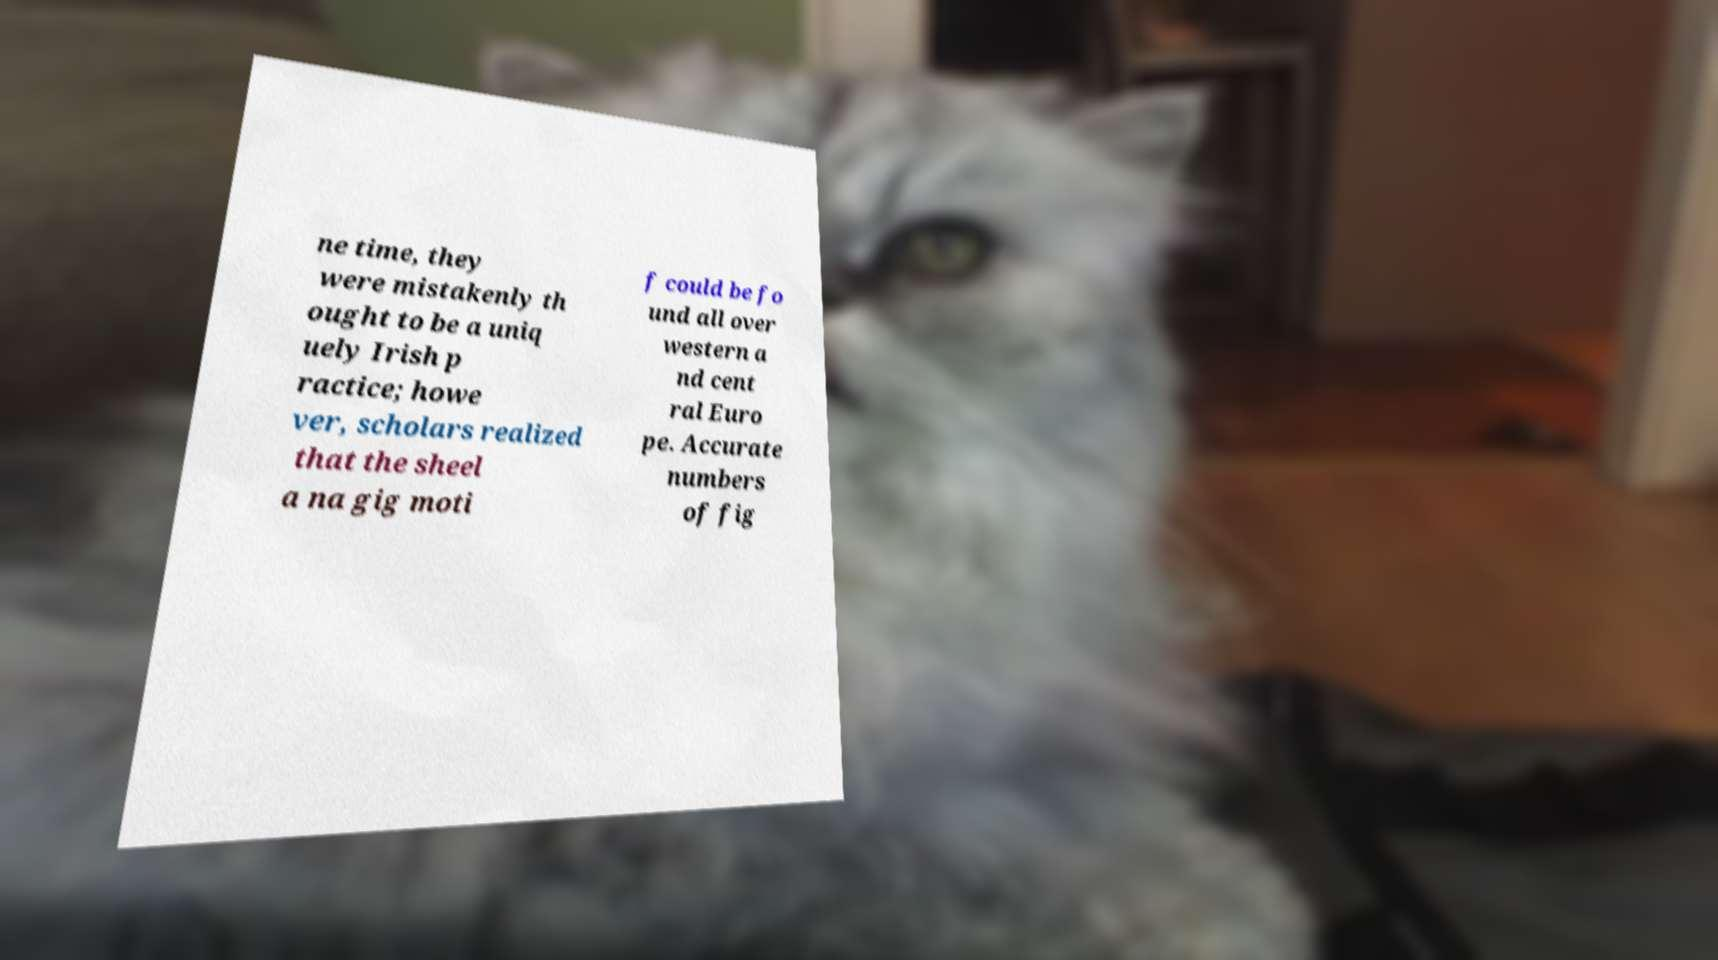Can you read and provide the text displayed in the image?This photo seems to have some interesting text. Can you extract and type it out for me? ne time, they were mistakenly th ought to be a uniq uely Irish p ractice; howe ver, scholars realized that the sheel a na gig moti f could be fo und all over western a nd cent ral Euro pe. Accurate numbers of fig 